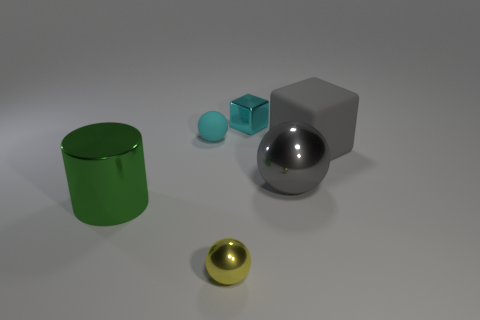What is the material of the object that is the same color as the matte ball?
Ensure brevity in your answer.  Metal. There is a block that is the same color as the big ball; what size is it?
Give a very brief answer. Large. What number of other things are there of the same shape as the yellow thing?
Your answer should be very brief. 2. There is a big green metal object; does it have the same shape as the small shiny thing that is in front of the big metallic cylinder?
Provide a short and direct response. No. There is a cylinder; how many big gray rubber things are left of it?
Your answer should be compact. 0. Is there anything else that has the same material as the big green cylinder?
Give a very brief answer. Yes. Do the cyan thing that is left of the tiny cyan metal thing and the big gray metal object have the same shape?
Provide a succinct answer. Yes. There is a object that is right of the big gray shiny thing; what color is it?
Keep it short and to the point. Gray. What shape is the large gray thing that is the same material as the yellow thing?
Offer a terse response. Sphere. Are there any other things that have the same color as the big matte object?
Ensure brevity in your answer.  Yes. 